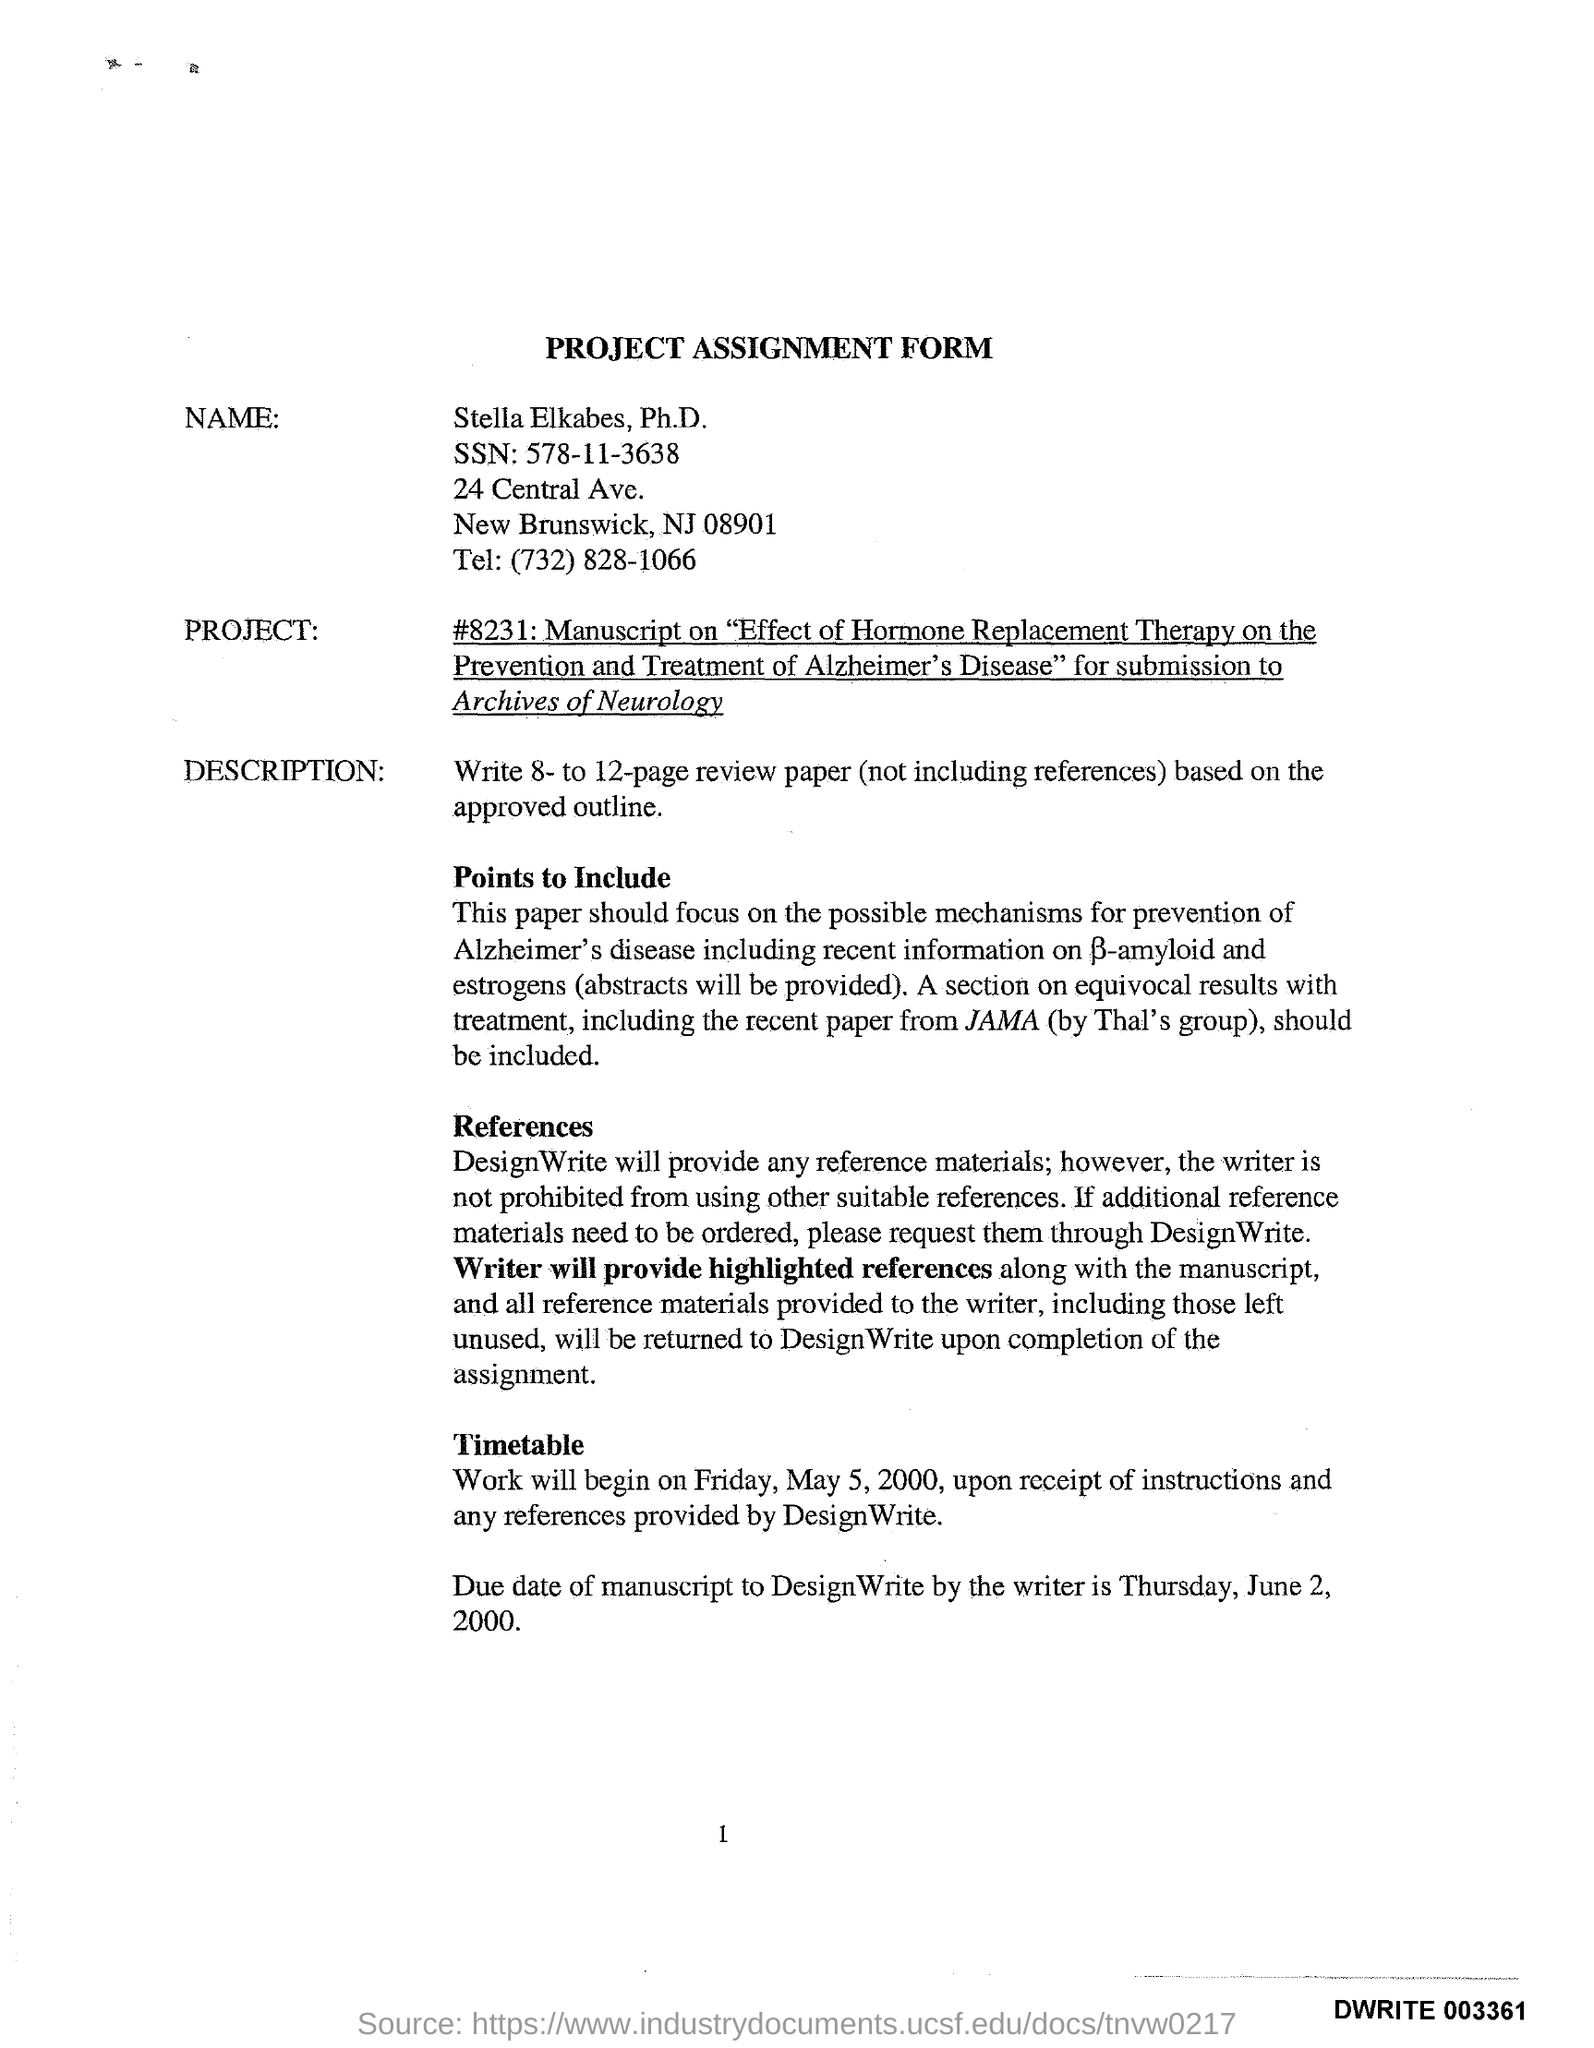Indicate a few pertinent items in this graphic. The name on the form is Stella Elkabes, Ph.D. The heading of the form is a Project Assignment Form. The due date for the manuscript to be submitted to DesignWrite by the writer is Thursday, June 2, 2000. The SSN is 578-11-3638. The telephone number is (732) 828-1066. 